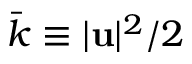Convert formula to latex. <formula><loc_0><loc_0><loc_500><loc_500>\bar { k } \equiv | u | ^ { 2 } / 2</formula> 